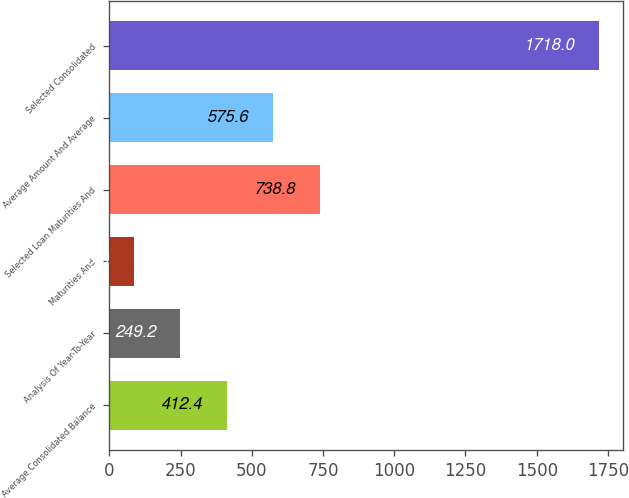<chart> <loc_0><loc_0><loc_500><loc_500><bar_chart><fcel>Average Consolidated Balance<fcel>Analysis Of Year-To-Year<fcel>Maturities And<fcel>Selected Loan Maturities And<fcel>Average Amount And Average<fcel>Selected Consolidated<nl><fcel>412.4<fcel>249.2<fcel>86<fcel>738.8<fcel>575.6<fcel>1718<nl></chart> 